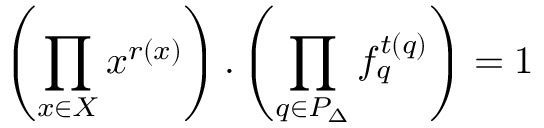<formula> <loc_0><loc_0><loc_500><loc_500>\left ( \prod _ { x \in X } x ^ { r ( x ) } \right ) . \left ( \prod _ { q \in P _ { \Delta } } f _ { q } ^ { t ( q ) } \right ) = 1</formula> 